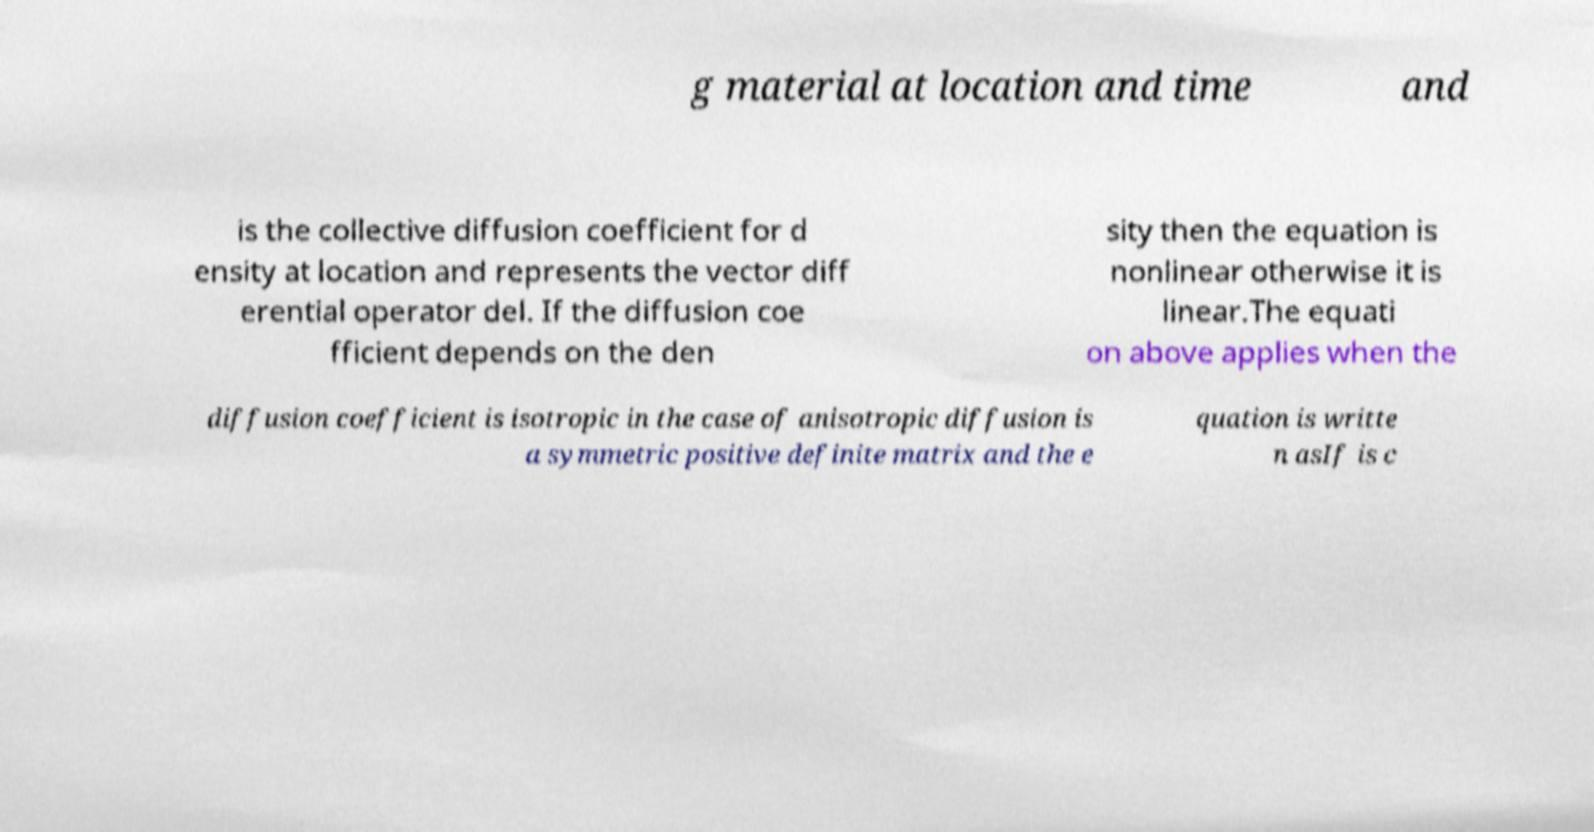For documentation purposes, I need the text within this image transcribed. Could you provide that? g material at location and time and is the collective diffusion coefficient for d ensity at location and represents the vector diff erential operator del. If the diffusion coe fficient depends on the den sity then the equation is nonlinear otherwise it is linear.The equati on above applies when the diffusion coefficient is isotropic in the case of anisotropic diffusion is a symmetric positive definite matrix and the e quation is writte n asIf is c 